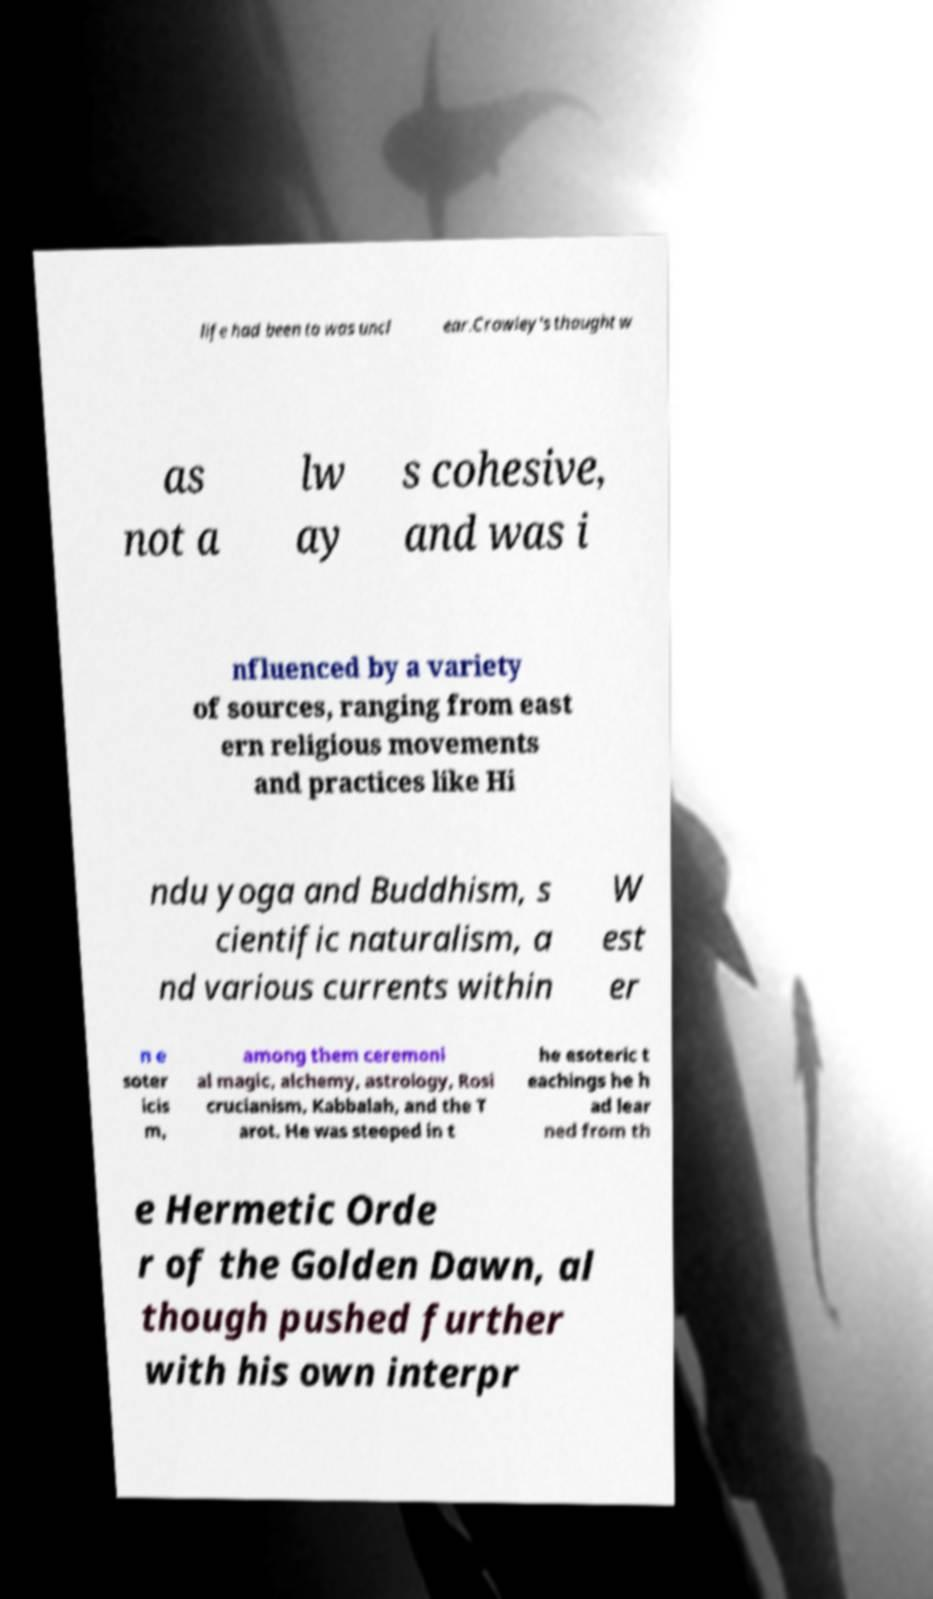Can you read and provide the text displayed in the image?This photo seems to have some interesting text. Can you extract and type it out for me? life had been to was uncl ear.Crowley's thought w as not a lw ay s cohesive, and was i nfluenced by a variety of sources, ranging from east ern religious movements and practices like Hi ndu yoga and Buddhism, s cientific naturalism, a nd various currents within W est er n e soter icis m, among them ceremoni al magic, alchemy, astrology, Rosi crucianism, Kabbalah, and the T arot. He was steeped in t he esoteric t eachings he h ad lear ned from th e Hermetic Orde r of the Golden Dawn, al though pushed further with his own interpr 